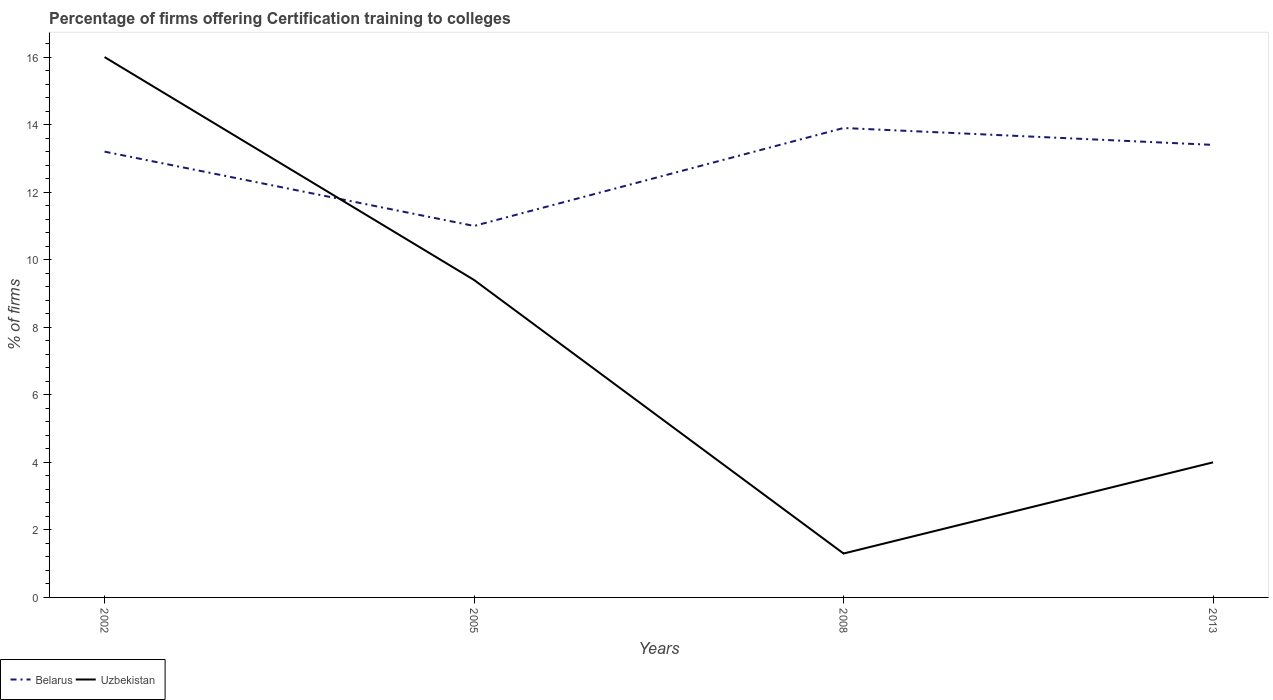Does the line corresponding to Uzbekistan intersect with the line corresponding to Belarus?
Ensure brevity in your answer.  Yes. Across all years, what is the maximum percentage of firms offering certification training to colleges in Uzbekistan?
Make the answer very short. 1.3. In which year was the percentage of firms offering certification training to colleges in Uzbekistan maximum?
Provide a succinct answer. 2008. What is the total percentage of firms offering certification training to colleges in Belarus in the graph?
Offer a terse response. -0.2. What is the difference between the highest and the second highest percentage of firms offering certification training to colleges in Uzbekistan?
Keep it short and to the point. 14.7. What is the difference between the highest and the lowest percentage of firms offering certification training to colleges in Belarus?
Offer a very short reply. 3. How many lines are there?
Your response must be concise. 2. How many years are there in the graph?
Make the answer very short. 4. What is the difference between two consecutive major ticks on the Y-axis?
Keep it short and to the point. 2. Are the values on the major ticks of Y-axis written in scientific E-notation?
Provide a succinct answer. No. Where does the legend appear in the graph?
Your answer should be compact. Bottom left. How are the legend labels stacked?
Give a very brief answer. Horizontal. What is the title of the graph?
Ensure brevity in your answer.  Percentage of firms offering Certification training to colleges. Does "Liberia" appear as one of the legend labels in the graph?
Offer a terse response. No. What is the label or title of the Y-axis?
Your response must be concise. % of firms. What is the % of firms in Uzbekistan in 2002?
Make the answer very short. 16. What is the % of firms of Belarus in 2005?
Offer a terse response. 11. What is the % of firms in Belarus in 2013?
Your response must be concise. 13.4. Across all years, what is the maximum % of firms in Belarus?
Your answer should be compact. 13.9. Across all years, what is the maximum % of firms of Uzbekistan?
Provide a short and direct response. 16. Across all years, what is the minimum % of firms in Belarus?
Give a very brief answer. 11. Across all years, what is the minimum % of firms of Uzbekistan?
Provide a succinct answer. 1.3. What is the total % of firms of Belarus in the graph?
Keep it short and to the point. 51.5. What is the total % of firms of Uzbekistan in the graph?
Give a very brief answer. 30.7. What is the difference between the % of firms in Uzbekistan in 2002 and that in 2013?
Give a very brief answer. 12. What is the difference between the % of firms of Belarus in 2005 and that in 2008?
Offer a very short reply. -2.9. What is the difference between the % of firms in Uzbekistan in 2005 and that in 2013?
Provide a succinct answer. 5.4. What is the difference between the % of firms of Belarus in 2008 and that in 2013?
Make the answer very short. 0.5. What is the difference between the % of firms in Uzbekistan in 2008 and that in 2013?
Your answer should be very brief. -2.7. What is the difference between the % of firms of Belarus in 2002 and the % of firms of Uzbekistan in 2005?
Offer a very short reply. 3.8. What is the difference between the % of firms of Belarus in 2005 and the % of firms of Uzbekistan in 2008?
Your answer should be very brief. 9.7. What is the average % of firms in Belarus per year?
Make the answer very short. 12.88. What is the average % of firms in Uzbekistan per year?
Give a very brief answer. 7.67. In the year 2002, what is the difference between the % of firms in Belarus and % of firms in Uzbekistan?
Keep it short and to the point. -2.8. In the year 2005, what is the difference between the % of firms in Belarus and % of firms in Uzbekistan?
Ensure brevity in your answer.  1.6. In the year 2008, what is the difference between the % of firms of Belarus and % of firms of Uzbekistan?
Ensure brevity in your answer.  12.6. What is the ratio of the % of firms in Belarus in 2002 to that in 2005?
Offer a very short reply. 1.2. What is the ratio of the % of firms of Uzbekistan in 2002 to that in 2005?
Your response must be concise. 1.7. What is the ratio of the % of firms in Belarus in 2002 to that in 2008?
Offer a very short reply. 0.95. What is the ratio of the % of firms in Uzbekistan in 2002 to that in 2008?
Ensure brevity in your answer.  12.31. What is the ratio of the % of firms in Belarus in 2002 to that in 2013?
Provide a succinct answer. 0.99. What is the ratio of the % of firms in Belarus in 2005 to that in 2008?
Your answer should be compact. 0.79. What is the ratio of the % of firms of Uzbekistan in 2005 to that in 2008?
Ensure brevity in your answer.  7.23. What is the ratio of the % of firms in Belarus in 2005 to that in 2013?
Offer a terse response. 0.82. What is the ratio of the % of firms of Uzbekistan in 2005 to that in 2013?
Keep it short and to the point. 2.35. What is the ratio of the % of firms of Belarus in 2008 to that in 2013?
Your answer should be compact. 1.04. What is the ratio of the % of firms of Uzbekistan in 2008 to that in 2013?
Make the answer very short. 0.33. What is the difference between the highest and the second highest % of firms in Belarus?
Offer a terse response. 0.5. What is the difference between the highest and the second highest % of firms of Uzbekistan?
Your answer should be compact. 6.6. What is the difference between the highest and the lowest % of firms of Belarus?
Give a very brief answer. 2.9. 